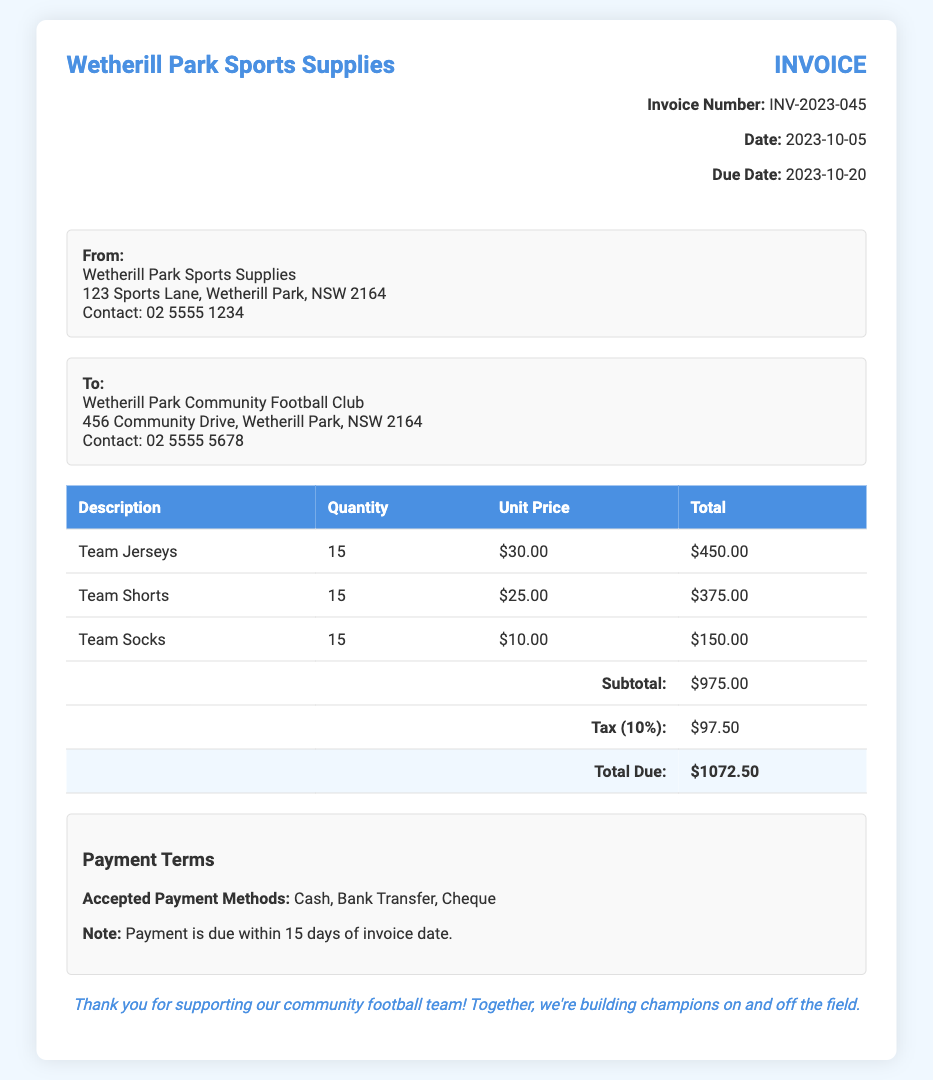What is the invoice number? The invoice number is listed in the invoice details section.
Answer: INV-2023-045 What is the total due amount? The total due amount is highlighted in the total row of the table.
Answer: $1072.50 What is the unit price of team jerseys? The unit price is shown in the table alongside the description of the team jerseys.
Answer: $30.00 How many team shorts were ordered? The quantity of team shorts is specified in the quantity column of the table.
Answer: 15 What are the accepted payment methods? The accepted payment methods are listed in the payment terms section.
Answer: Cash, Bank Transfer, Cheque What is the tax percentage applied? The tax percentage can be inferred from the description next to the tax amount in the table.
Answer: 10% What is the date when the invoice was issued? The date is provided in the invoice details section.
Answer: 2023-10-05 When is the payment due? The due date is specified in the invoice details section.
Answer: 2023-10-20 What is the subtotal amount before taxes? The subtotal amount is shown in the relevant row in the table.
Answer: $975.00 